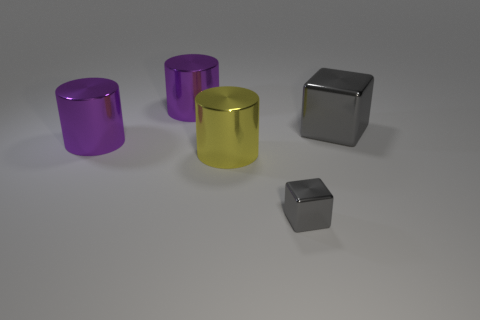Add 1 large yellow cylinders. How many objects exist? 6 Subtract all cylinders. How many objects are left? 2 Add 2 big yellow metallic cylinders. How many big yellow metallic cylinders are left? 3 Add 4 large purple shiny things. How many large purple shiny things exist? 6 Subtract 0 brown balls. How many objects are left? 5 Subtract all brown metal cylinders. Subtract all small gray shiny blocks. How many objects are left? 4 